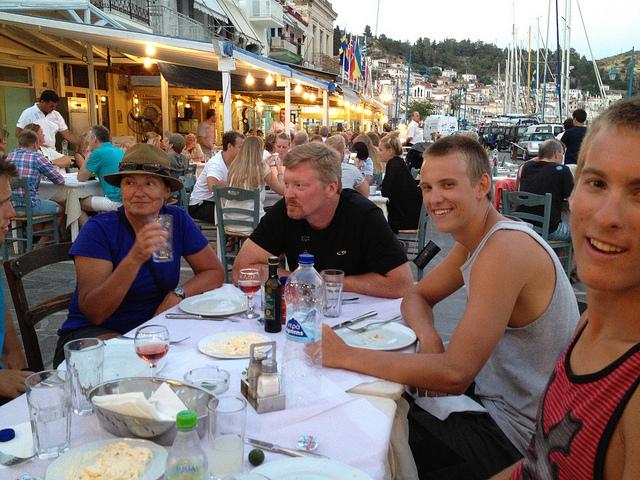What color is the tablecloth?
Give a very brief answer. White. What is on the women's head?
Give a very brief answer. Hat. Are these people on vacation?
Give a very brief answer. Yes. 